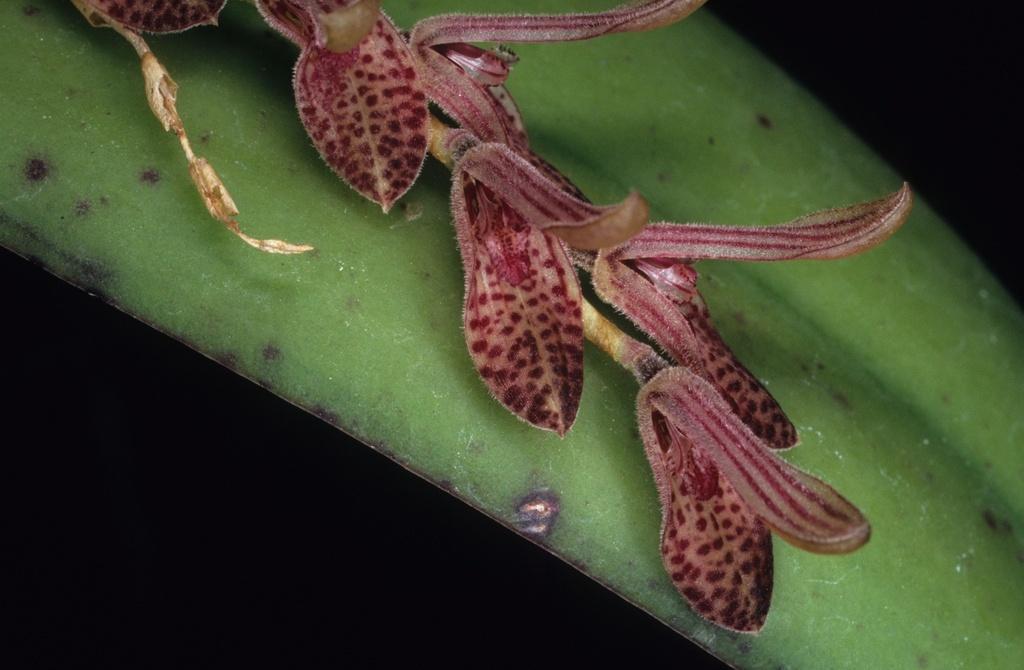Describe this image in one or two sentences. Here in this picture we can see a flower present on the plant over there. 